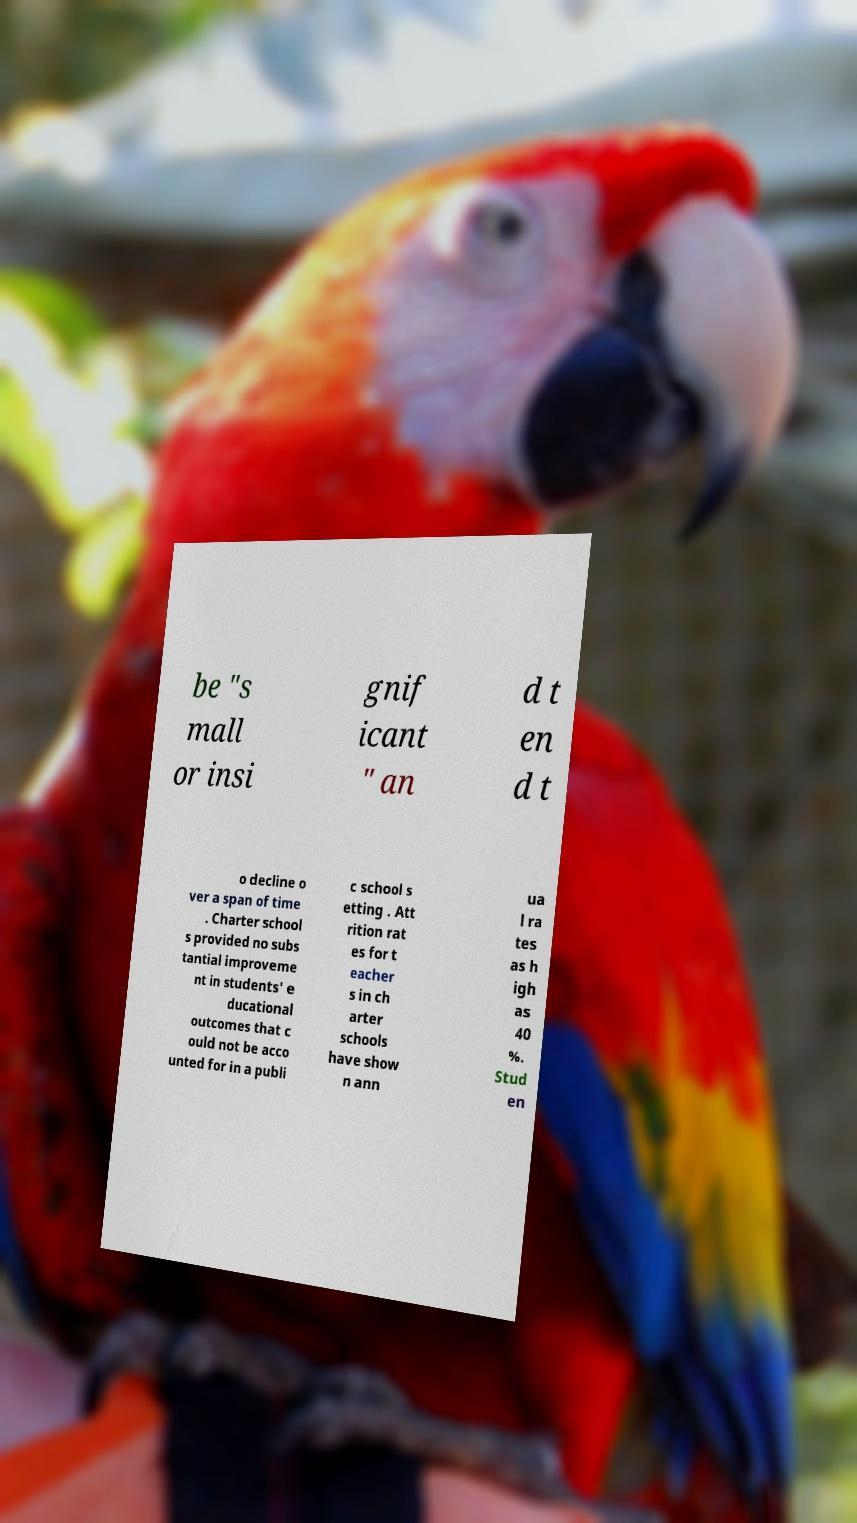There's text embedded in this image that I need extracted. Can you transcribe it verbatim? be "s mall or insi gnif icant " an d t en d t o decline o ver a span of time . Charter school s provided no subs tantial improveme nt in students' e ducational outcomes that c ould not be acco unted for in a publi c school s etting . Att rition rat es for t eacher s in ch arter schools have show n ann ua l ra tes as h igh as 40 %. Stud en 